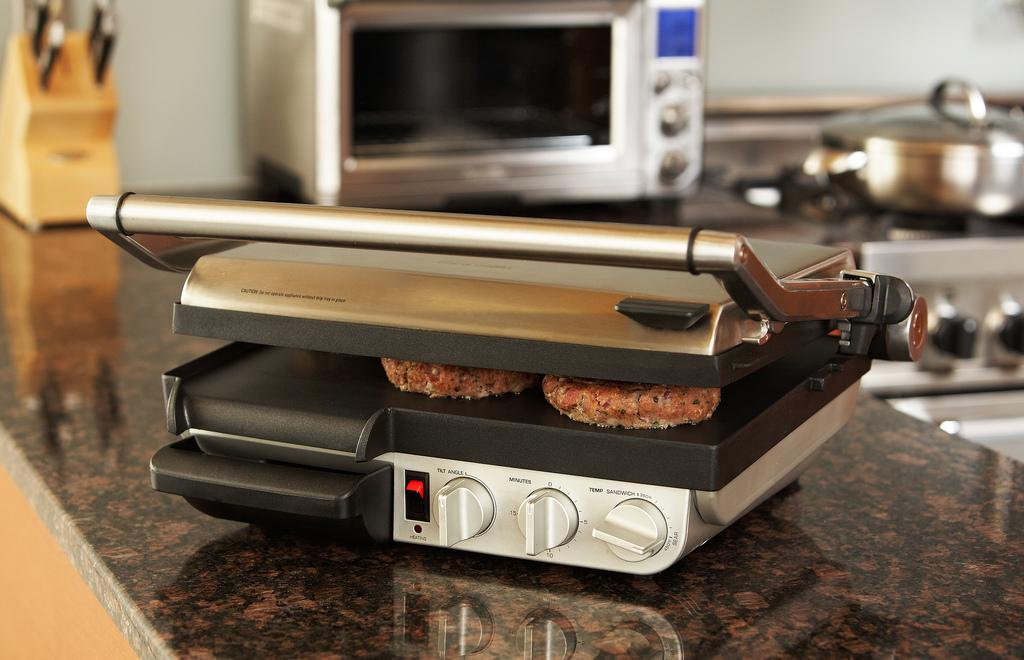<image>
Share a concise interpretation of the image provided. a knob with the word temp on it cooking burgers 